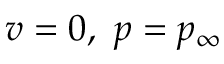<formula> <loc_0><loc_0><loc_500><loc_500>v = 0 , \ p = p _ { \infty }</formula> 